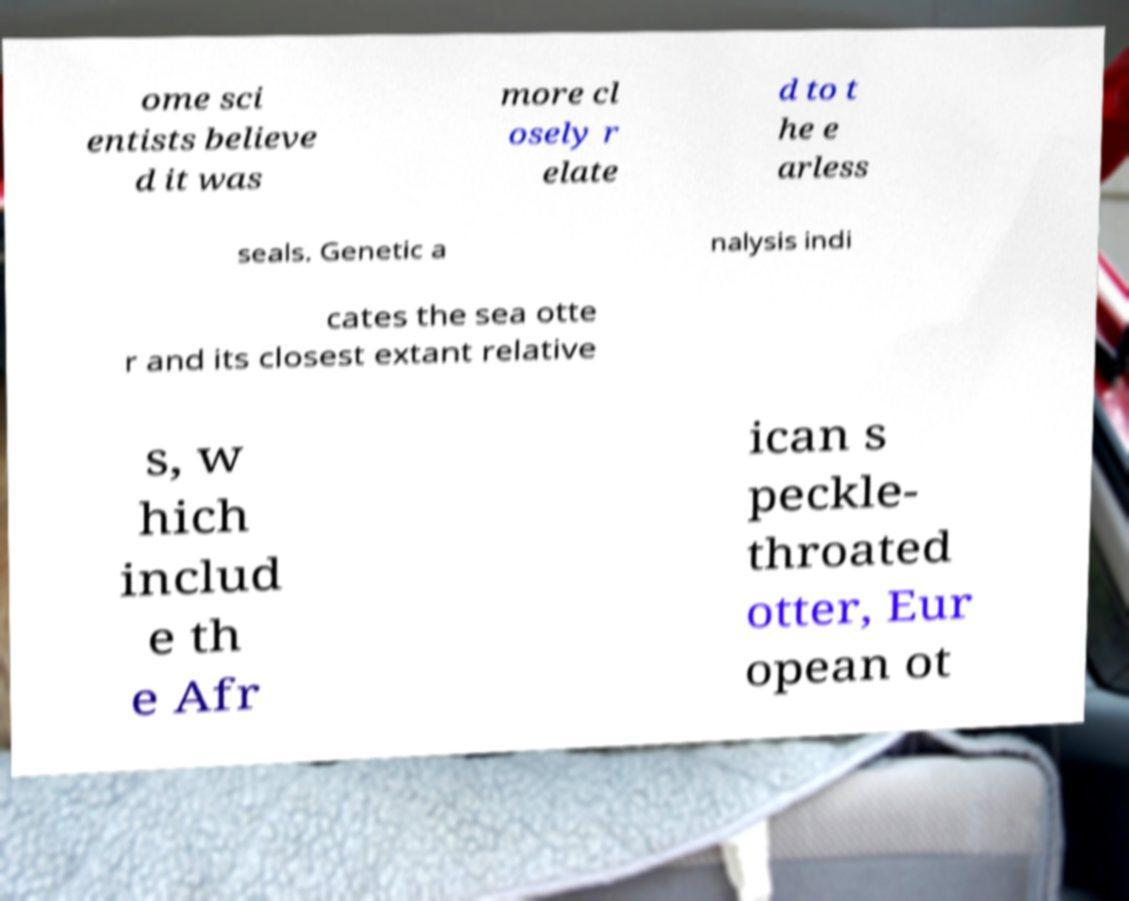What messages or text are displayed in this image? I need them in a readable, typed format. ome sci entists believe d it was more cl osely r elate d to t he e arless seals. Genetic a nalysis indi cates the sea otte r and its closest extant relative s, w hich includ e th e Afr ican s peckle- throated otter, Eur opean ot 